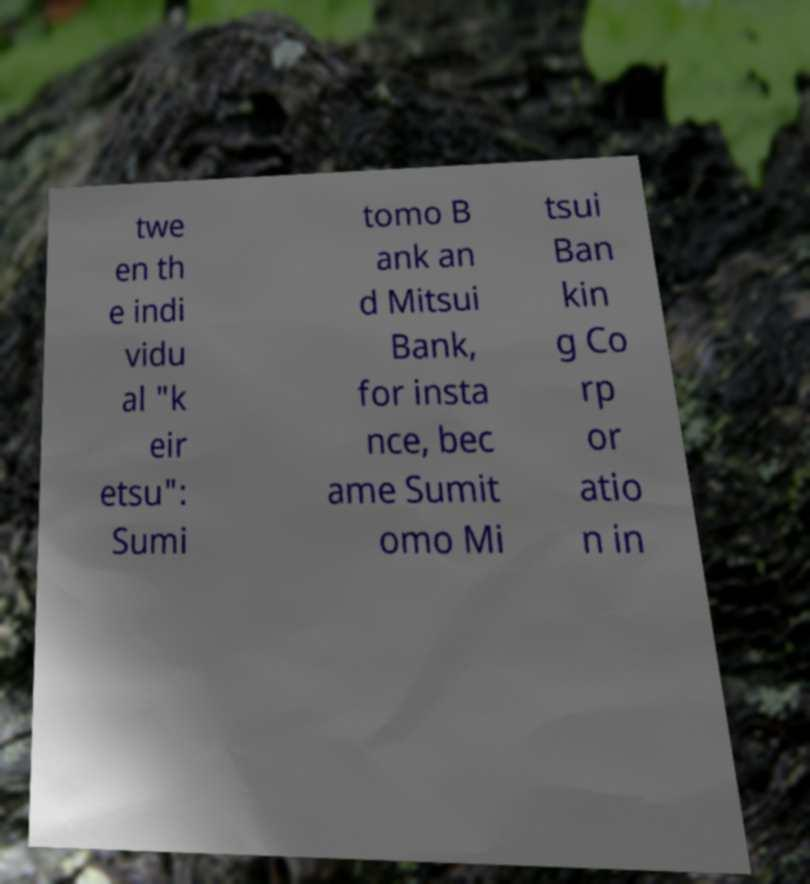For documentation purposes, I need the text within this image transcribed. Could you provide that? twe en th e indi vidu al "k eir etsu": Sumi tomo B ank an d Mitsui Bank, for insta nce, bec ame Sumit omo Mi tsui Ban kin g Co rp or atio n in 